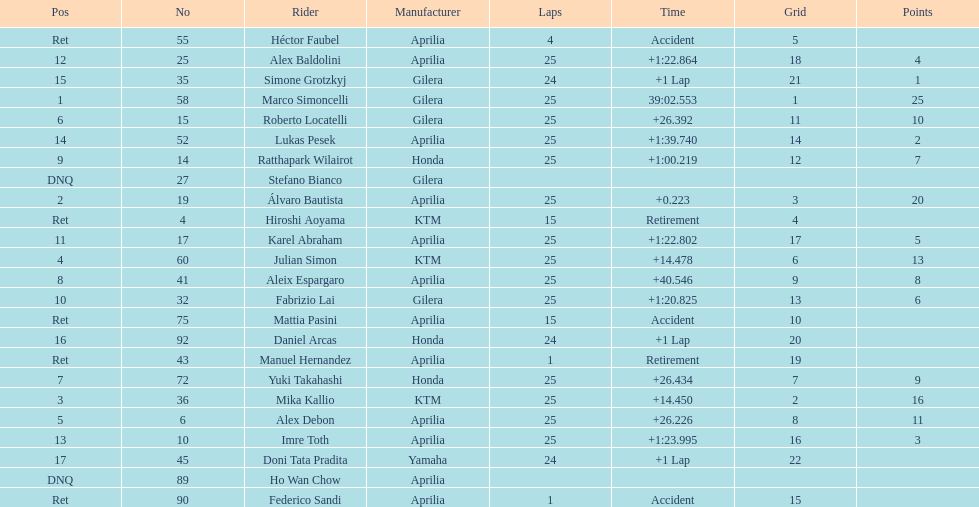Did marco simoncelli or alvaro bautista held rank 1? Marco Simoncelli. 